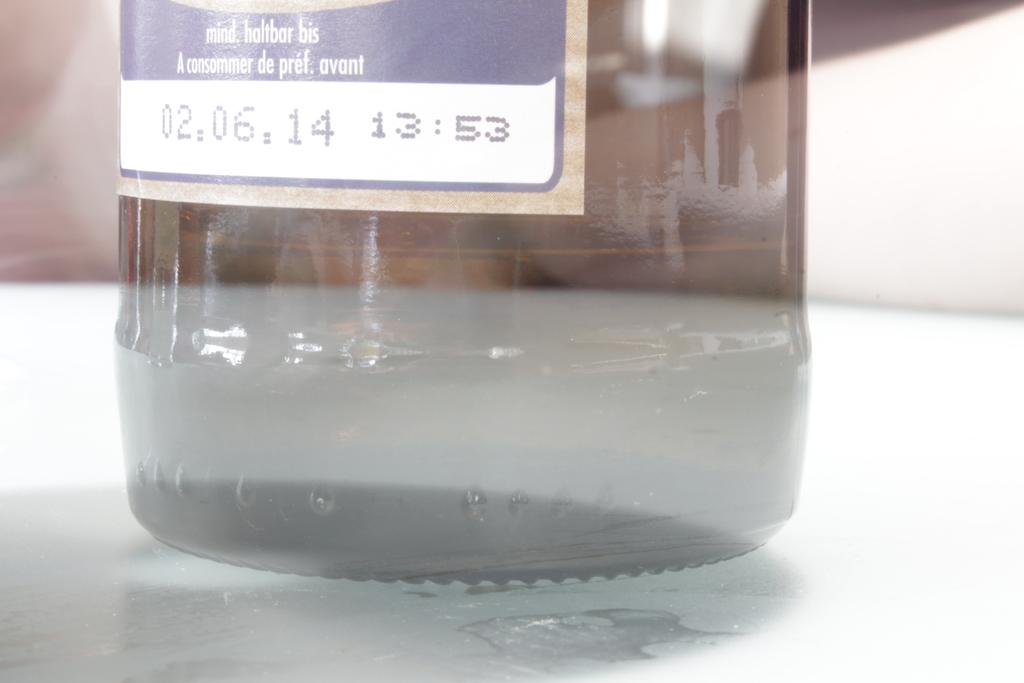<image>
Offer a succinct explanation of the picture presented. a bottle with the date 02,06,14 on the bottom label 